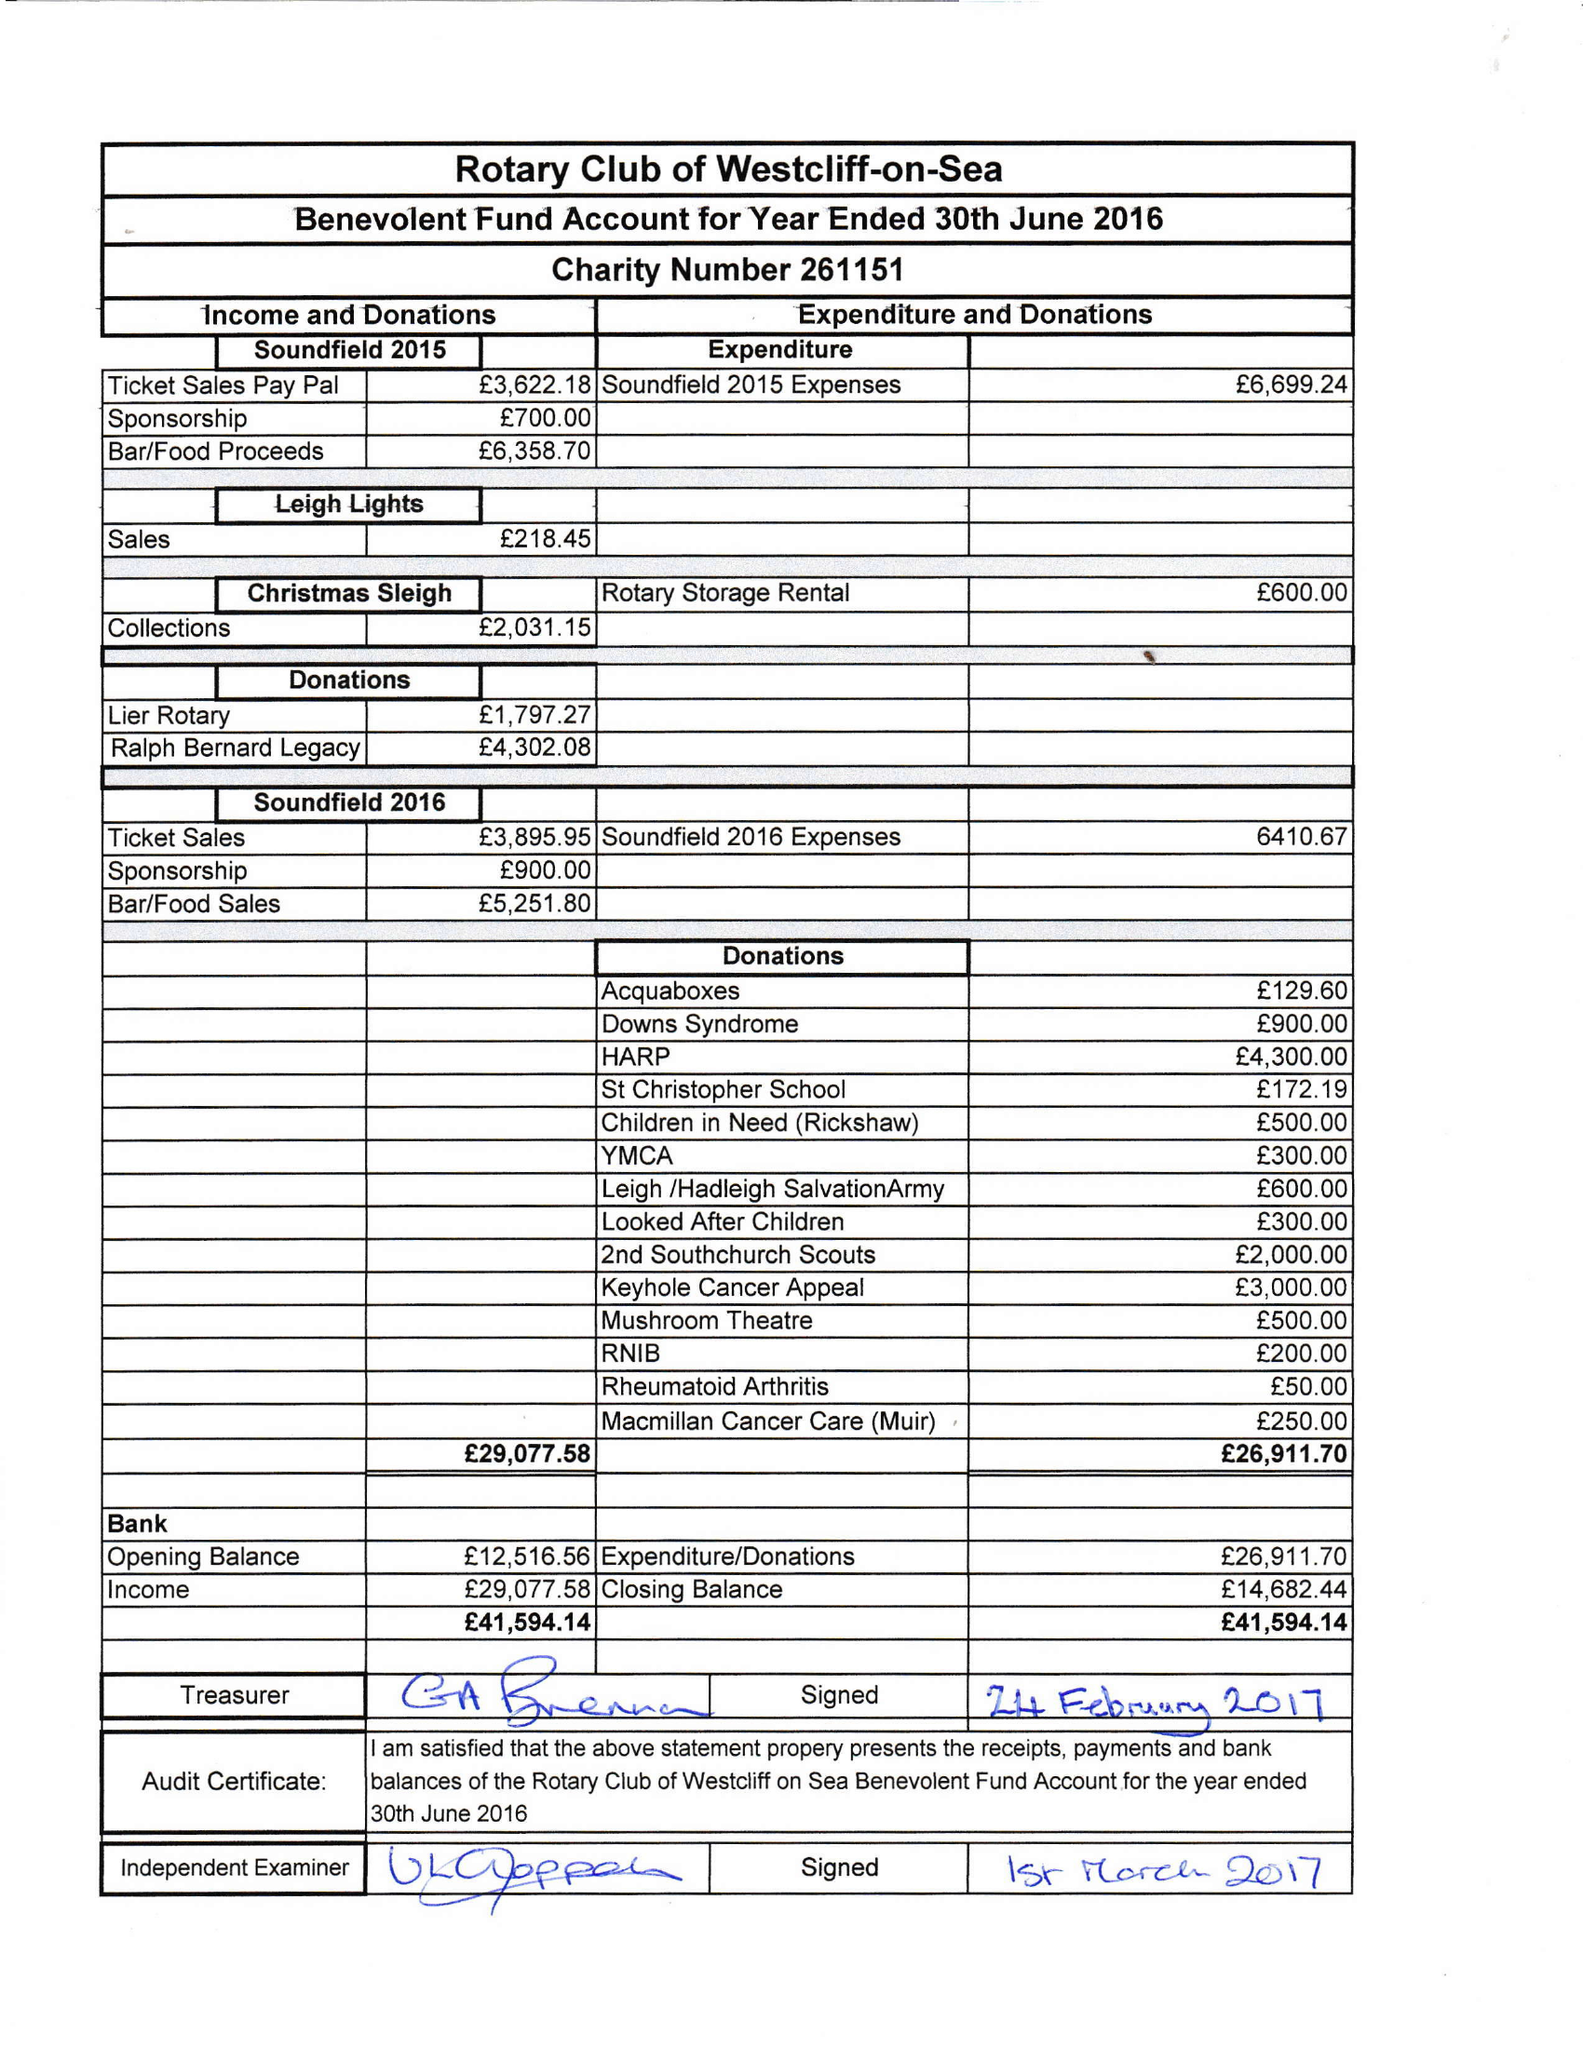What is the value for the address__street_line?
Answer the question using a single word or phrase. 36 KENILWORTH GARDENS 